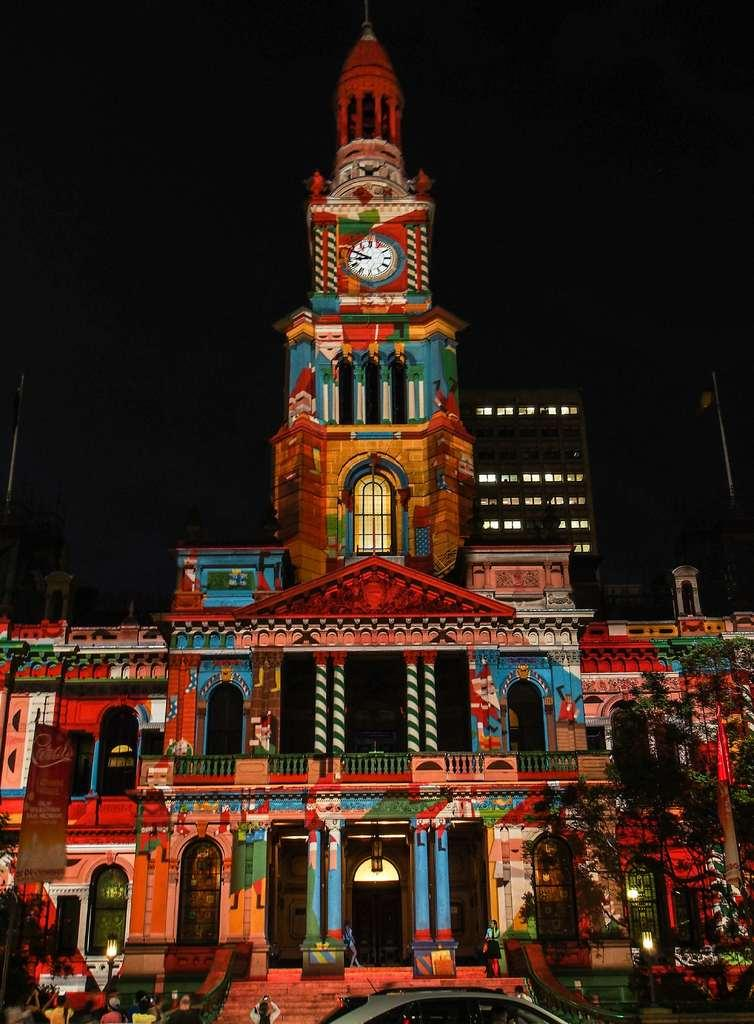What type of structure is in the image? There is a building in the image. What feature is present on the building? The building has a tower. What is on the tower? The tower has a clock. What can be observed about the sky in the image? The sky is dark and clear. What small detail can be seen on the clock in the image? There is no specific detail mentioned about the clock in the image, so it cannot be determined from the provided facts. 